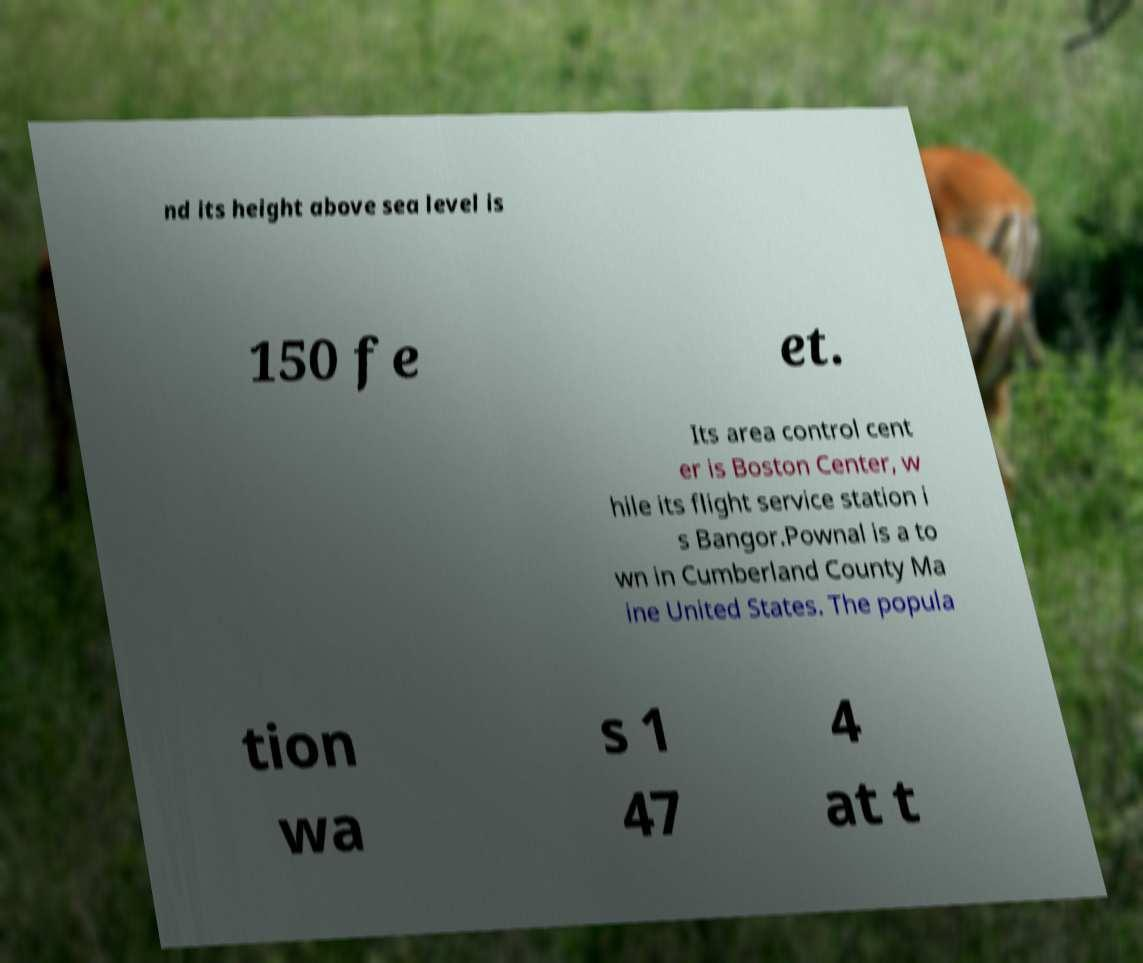I need the written content from this picture converted into text. Can you do that? nd its height above sea level is 150 fe et. Its area control cent er is Boston Center, w hile its flight service station i s Bangor.Pownal is a to wn in Cumberland County Ma ine United States. The popula tion wa s 1 47 4 at t 